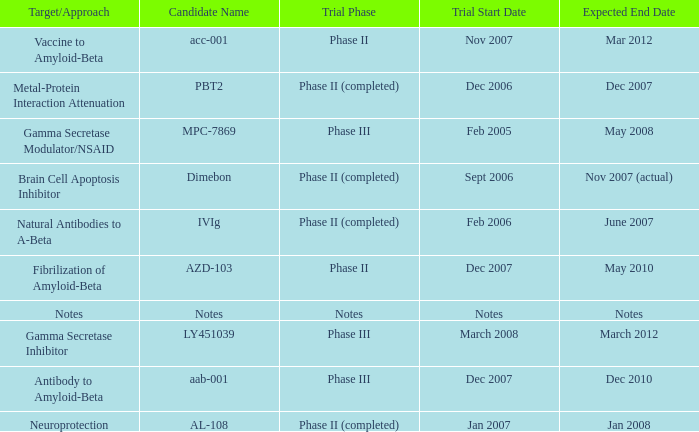What is Trial Phase, when Expected End Date is June 2007? Phase II (completed). 